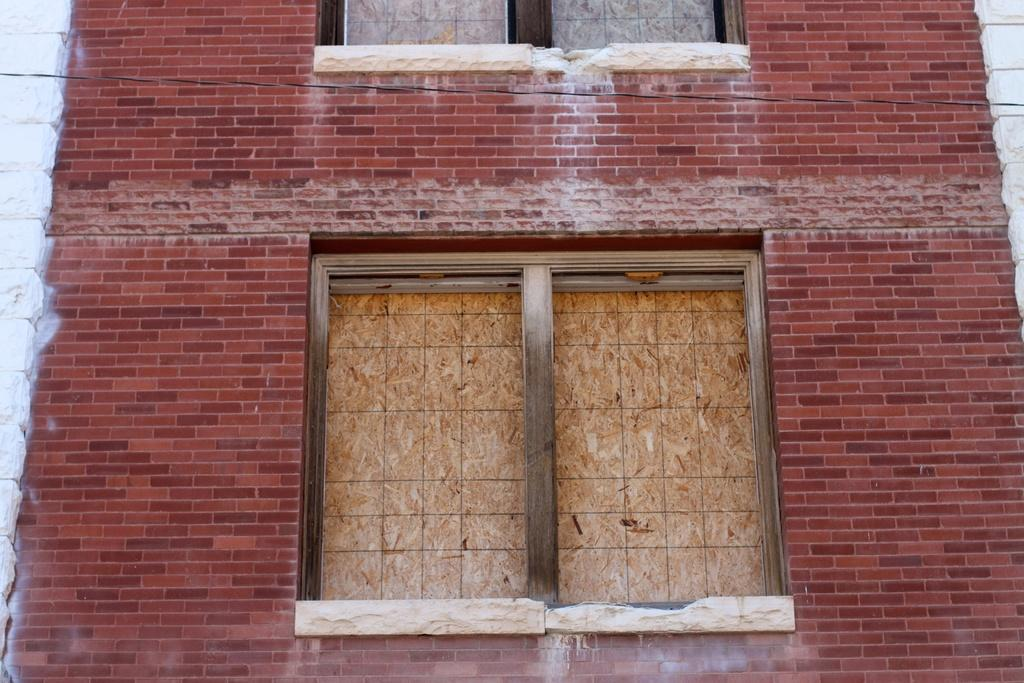What type of structure is present in the image? There is a building in the image. What are the walls made of in the image? The walls are visible in the image, but the material is not specified. What can be seen through the windows in the image? The contents or view through the windows are not visible in the image. What type of meat is being served at the table in the image? There is no table or meat present in the image; it only features a building with walls and windows. 